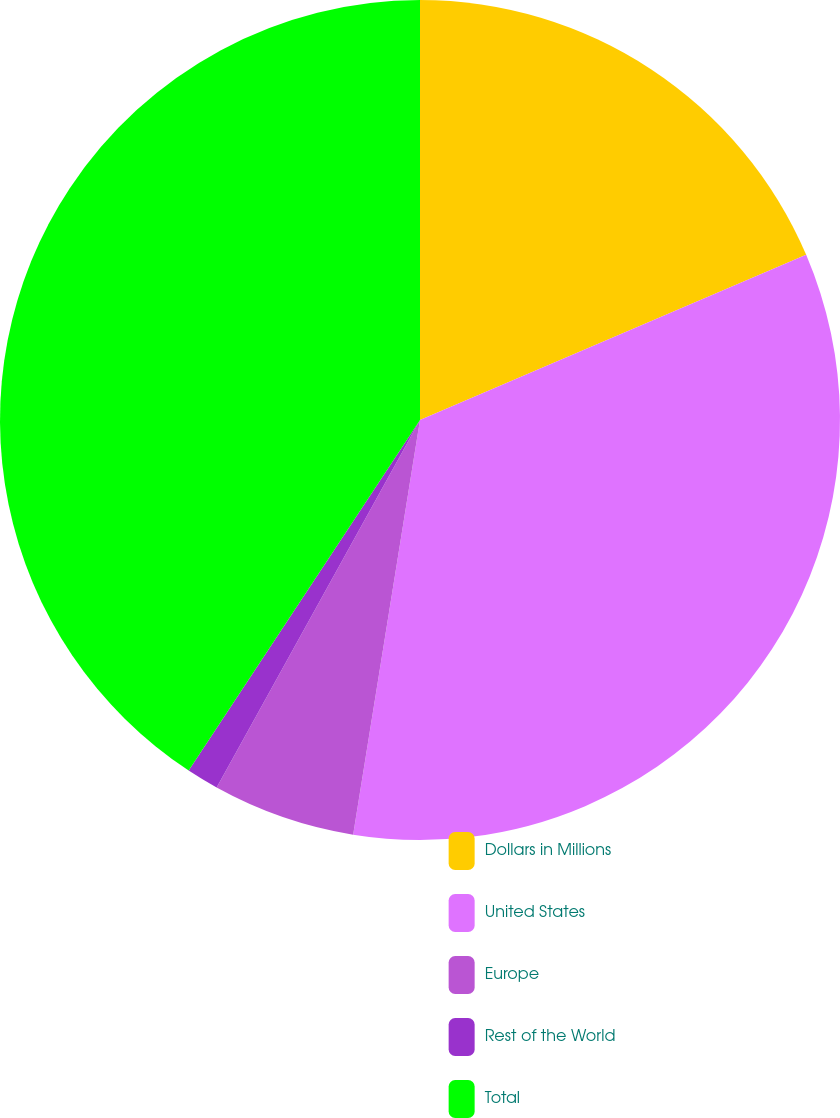Convert chart. <chart><loc_0><loc_0><loc_500><loc_500><pie_chart><fcel>Dollars in Millions<fcel>United States<fcel>Europe<fcel>Rest of the World<fcel>Total<nl><fcel>18.57%<fcel>33.98%<fcel>5.5%<fcel>1.24%<fcel>40.72%<nl></chart> 